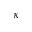Convert formula to latex. <formula><loc_0><loc_0><loc_500><loc_500>\kappa</formula> 